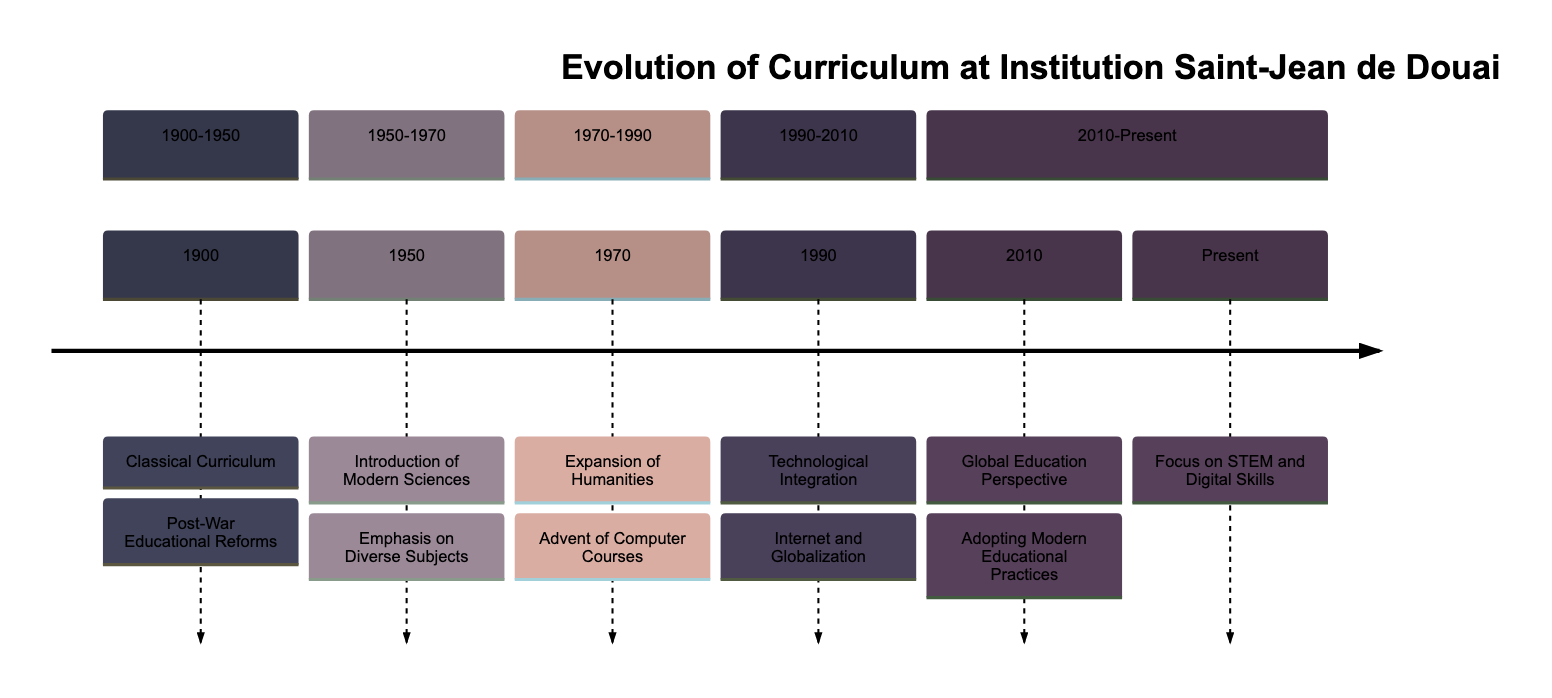What curriculum was introduced in 1950? According to the diagram, the curriculum that was introduced in 1950 is the "Introduction of Modern Sciences." This information is obtained by locating the section that corresponds to the time period of 1950 and finding the relevant node.
Answer: Introduction of Modern Sciences Which section comes immediately after 1990? Looking at the timeline, the section that comes immediately after 1990, which is labeled as "1990: Technological Integration," is the section named "1990-2010." This indicates that the next chronological segment follows 1990 in the progression of the timeline.
Answer: 1990-2010 What is the main focus of the curriculum in the present? The diagram states that the current focus of the curriculum at Institution Saint-Jean de Douai is on "Focus on STEM and Digital Skills." This is at the end of the timeline.
Answer: Focus on STEM and Digital Skills How many major sections are shown in the diagram? By counting the named sections in the diagram, we can see that there are five major sections: "1900-1950," "1950-1970," "1970-1990," "1990-2010," and "2010-Present." Thus, the total number of sections is five.
Answer: Five What key reform occurred in 1970? The diagram reveals that the key reform that occurred in 1970 is the "Expansion of Humanities." This is a straightforward identification of the specific node corresponding to that year within the timeline.
Answer: Expansion of Humanities What educational trend began in 1990? The diagram indicates that the educational trend that began in 1990 is "Technological Integration." This is seen in the section for the year 1990 in the timeline, highlighting the introduction of technology into the curriculum.
Answer: Technological Integration Which educational perspective was adopted in 2010? Referring to the diagram, the educational perspective adopted in 2010 is the "Global Education Perspective." This can be found in the relevant section corresponding to that year on the timeline.
Answer: Global Education Perspective Why did the emphasis on diverse subjects start in 1950? To answer this, one should consider the timeline's context. In 1950, the introduction of Modern Sciences led to an "Emphasis on Diverse Subjects." The reasoning identifies this connection as part of a broader educational reform.
Answer: Emphasis on Diverse Subjects What significant change occurred in 1970 regarding courses? According to the diagram, the significant change that occurred in 1970 was the "Advent of Computer Courses." This indicates the integration of computer education into the curriculum at that time.
Answer: Advent of Computer Courses 